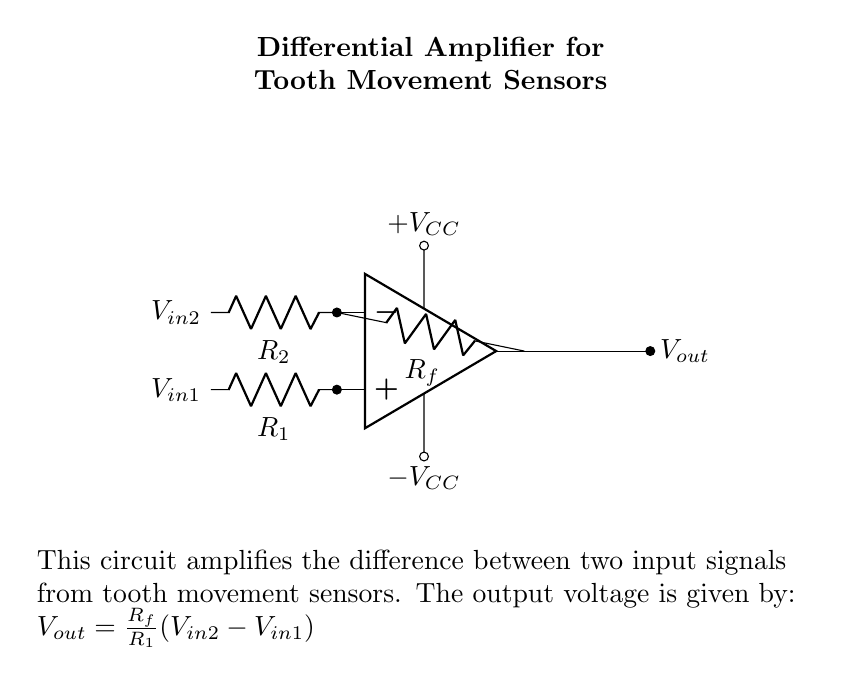What type of amplifier is shown in the circuit? The circuit is specifically labeled as a differential amplifier, which amplifies the difference between two input voltages.
Answer: differential amplifier What are the input signals represented in the circuit? The input signals are represented as V in1 and V in2, which are connected to the operational amplifier's positive and negative terminals respectively.
Answer: V in1 and V in2 What is the role of the feedback resistor R f? The feedback resistor R f is involved in determining the gain of the amplifier, affecting the relationship between the output voltage and the input voltage difference.
Answer: gain adjustment How does the output voltage relate to the input voltages? The output voltage is determined by the formula V out = (R f / R 1) * (V in2 - V in1), indicating that it is a function of the difference between the input voltages scaled by the feedback resistor and input resistor values.
Answer: difference amplified What happens to the output voltage if V in1 increases? If V in1 increases while V in2 remains constant, the output voltage will decrease since the difference (V in2 - V in1) decreases, leading to a negative impact on the output.
Answer: decreases What does the power supply indicate in the circuit? The power supply with +V CC and -V CC indicates that the operational amplifier needs both positive and negative voltage supplies to function properly.
Answer: dual power supply How does the circuit help in monitoring tooth movement? The differential amplifier processes signals from tooth movement sensors, amplifying the changes in voltage that represent the movement, thus allowing accurate monitoring.
Answer: amplifies movement signals 